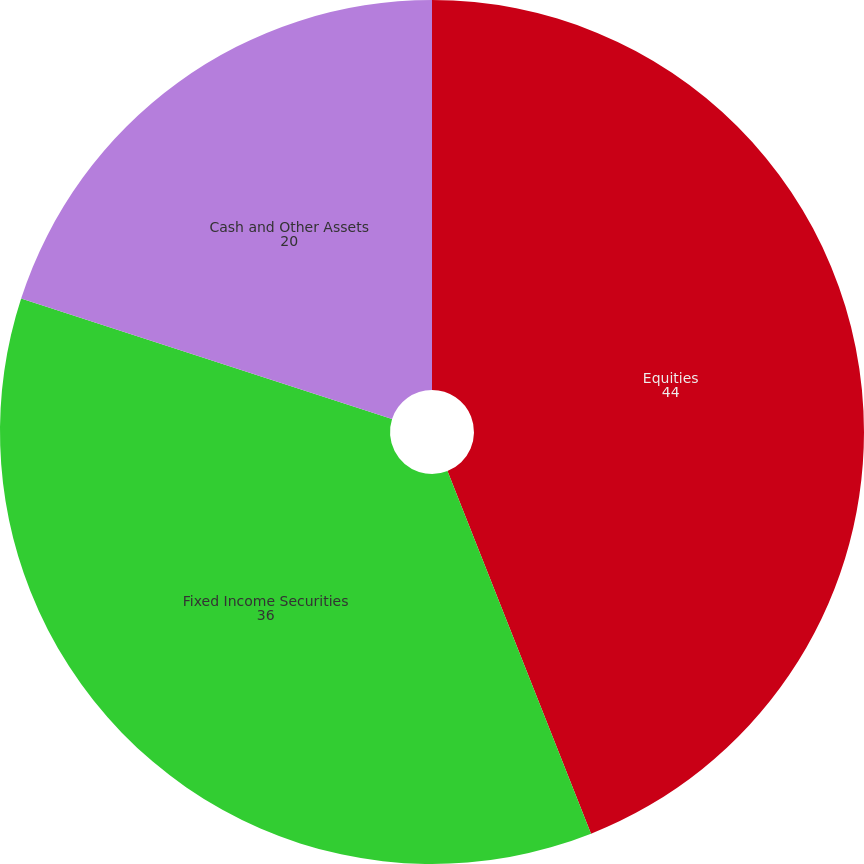Convert chart. <chart><loc_0><loc_0><loc_500><loc_500><pie_chart><fcel>Equities<fcel>Fixed Income Securities<fcel>Cash and Other Assets<nl><fcel>44.0%<fcel>36.0%<fcel>20.0%<nl></chart> 